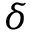Convert formula to latex. <formula><loc_0><loc_0><loc_500><loc_500>\delta</formula> 